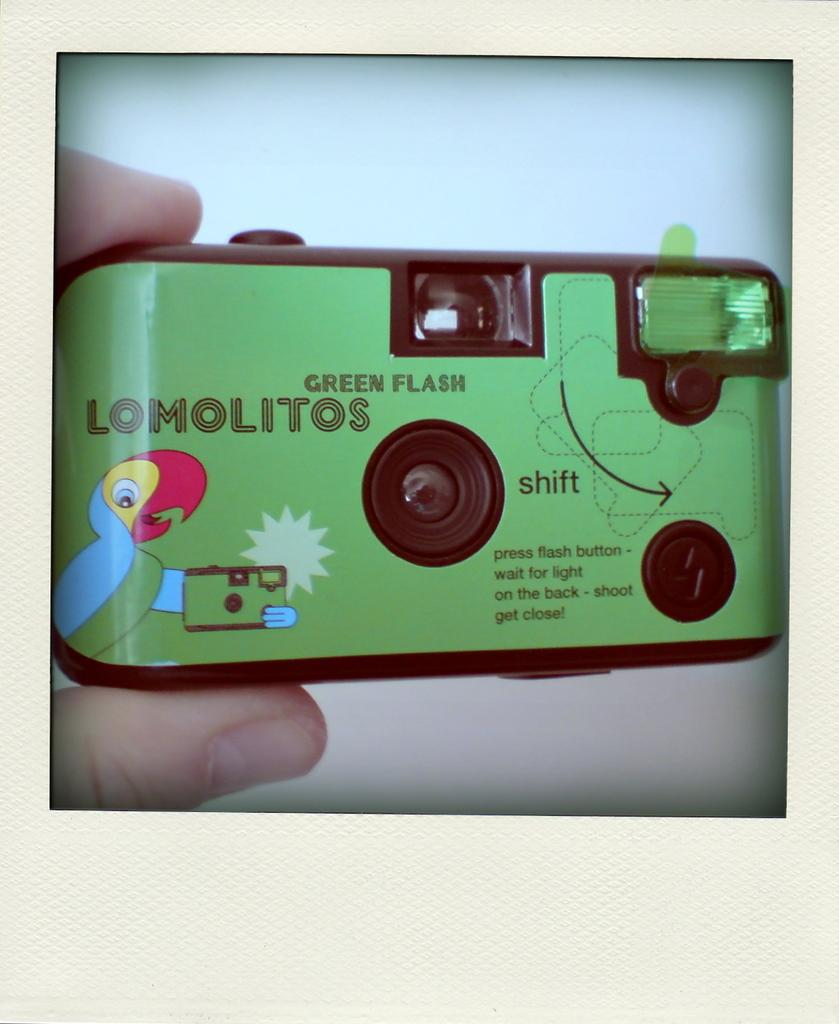What is being held by the fingers in the image? Human fingers holding a camera are visible in the image. What can be seen on the camera itself? There is text and a figure on the camera. What is a key feature of the camera? The camera has a lens. What is another feature of the camera? The camera has a flashlight. What is the color of the background in the image? The background of the image is white. What year is the fireman mentioned in the text on the camera? There is no mention of a fireman or any year in the text on the camera. 